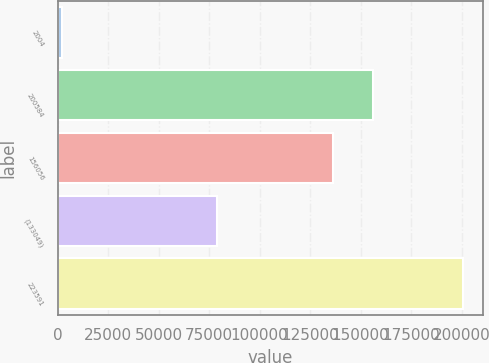Convert chart. <chart><loc_0><loc_0><loc_500><loc_500><bar_chart><fcel>2004<fcel>200584<fcel>156056<fcel>(133049)<fcel>223591<nl><fcel>2003<fcel>156166<fcel>136308<fcel>78708<fcel>200584<nl></chart> 